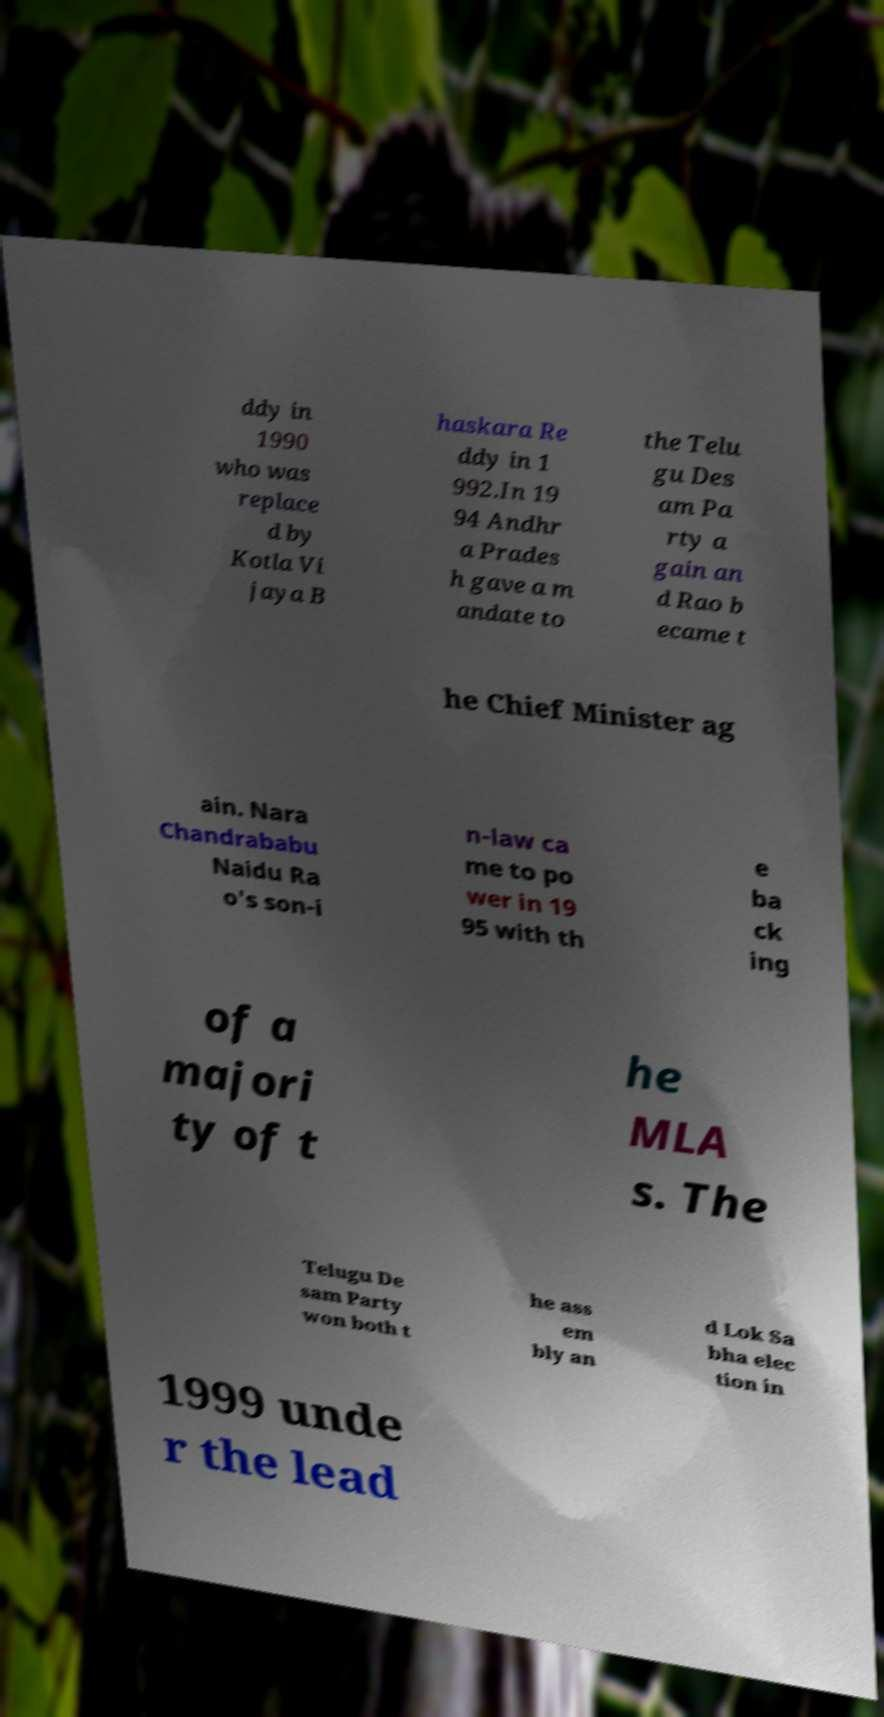There's text embedded in this image that I need extracted. Can you transcribe it verbatim? ddy in 1990 who was replace d by Kotla Vi jaya B haskara Re ddy in 1 992.In 19 94 Andhr a Prades h gave a m andate to the Telu gu Des am Pa rty a gain an d Rao b ecame t he Chief Minister ag ain. Nara Chandrababu Naidu Ra o's son-i n-law ca me to po wer in 19 95 with th e ba ck ing of a majori ty of t he MLA s. The Telugu De sam Party won both t he ass em bly an d Lok Sa bha elec tion in 1999 unde r the lead 